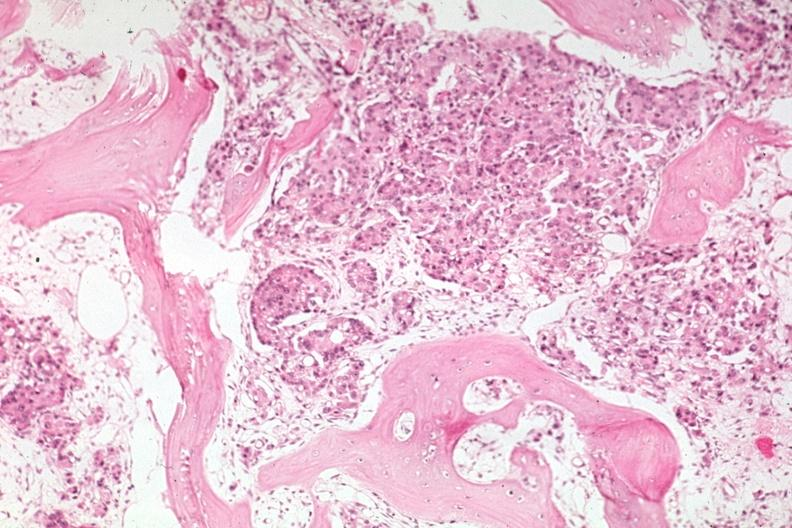what is present?
Answer the question using a single word or phrase. Joints 